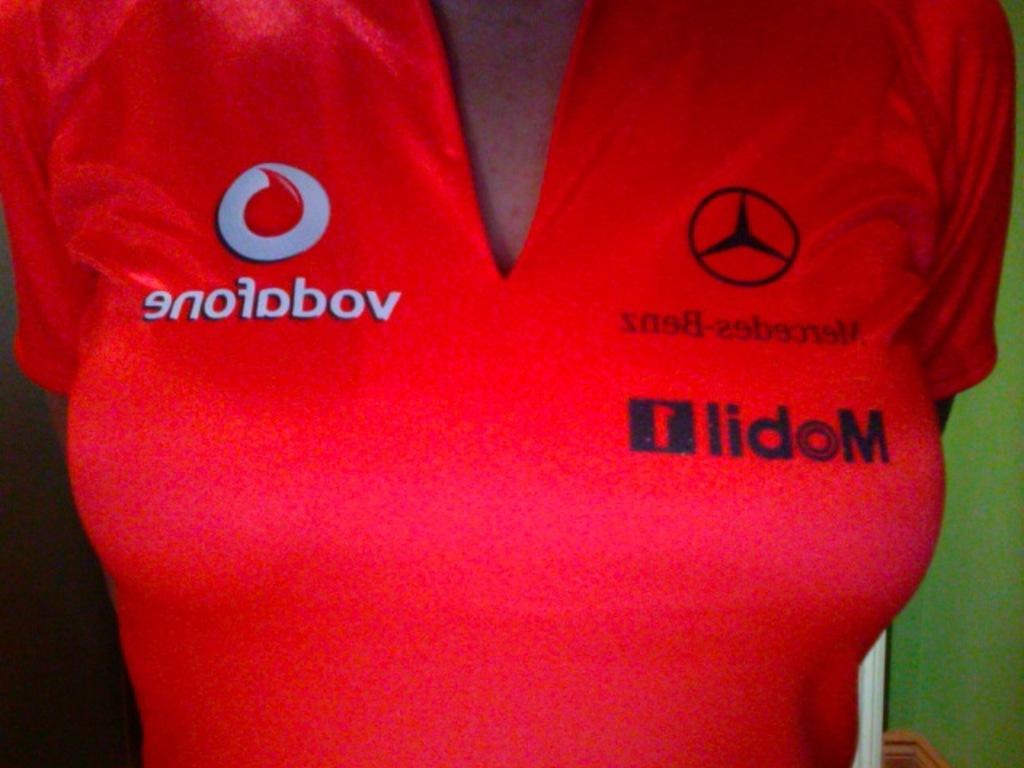What vehicle manufacturer is on the shirt?
Provide a succinct answer. Mercedes-benz. What gas company is on the shirt?
Provide a succinct answer. Mobil. 